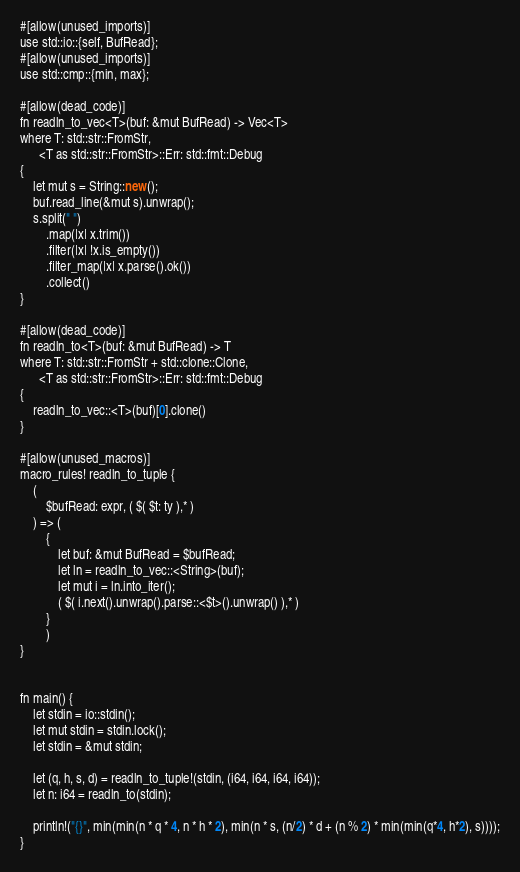<code> <loc_0><loc_0><loc_500><loc_500><_D_>#[allow(unused_imports)]
use std::io::{self, BufRead};
#[allow(unused_imports)]
use std::cmp::{min, max};

#[allow(dead_code)]
fn readln_to_vec<T>(buf: &mut BufRead) -> Vec<T> 
where T: std::str::FromStr,
      <T as std::str::FromStr>::Err: std::fmt::Debug
{
    let mut s = String::new();
    buf.read_line(&mut s).unwrap();
    s.split(" ")
        .map(|x| x.trim())
        .filter(|x| !x.is_empty())
        .filter_map(|x| x.parse().ok())
        .collect()
}

#[allow(dead_code)]
fn readln_to<T>(buf: &mut BufRead) -> T
where T: std::str::FromStr + std::clone::Clone,
      <T as std::str::FromStr>::Err: std::fmt::Debug
{
    readln_to_vec::<T>(buf)[0].clone()
}

#[allow(unused_macros)]
macro_rules! readln_to_tuple {
    (
        $bufRead: expr, ( $( $t: ty ),* )
    ) => (
        {
            let buf: &mut BufRead = $bufRead;
            let ln = readln_to_vec::<String>(buf);
            let mut i = ln.into_iter();
            ( $( i.next().unwrap().parse::<$t>().unwrap() ),* )
        }
        )
}


fn main() {
    let stdin = io::stdin();
    let mut stdin = stdin.lock();
    let stdin = &mut stdin;

    let (q, h, s, d) = readln_to_tuple!(stdin, (i64, i64, i64, i64));
    let n: i64 = readln_to(stdin);

    println!("{}", min(min(n * q * 4, n * h * 2), min(n * s, (n/2) * d + (n % 2) * min(min(q*4, h*2), s))));
}


</code> 